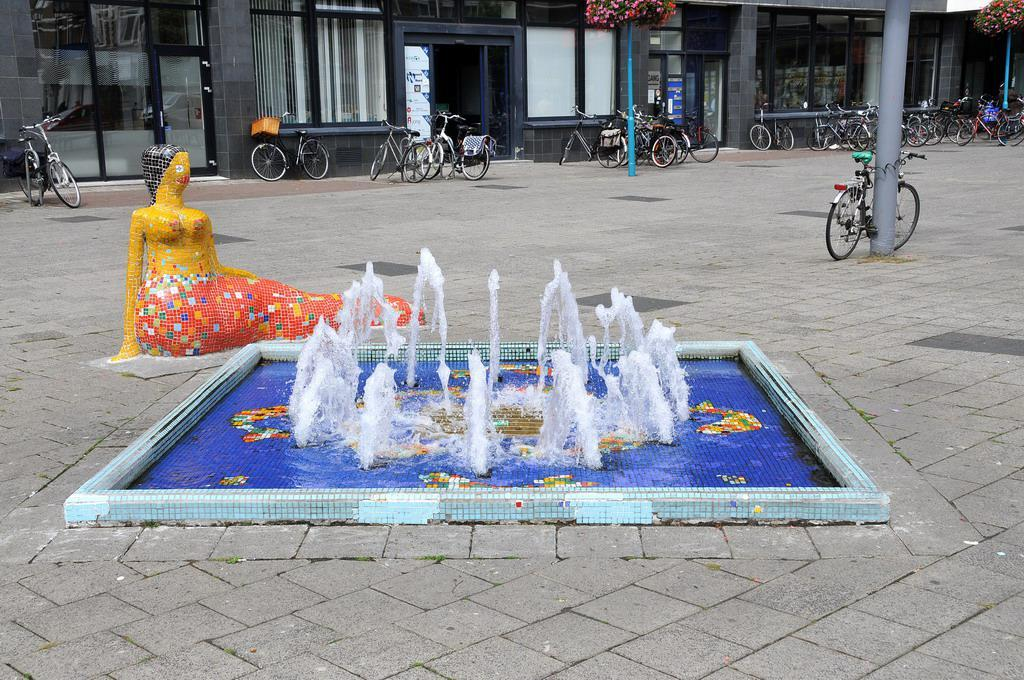What is the main feature in the image? There is a fountain with water in the image. Are there any other objects or structures near the fountain? Yes, there is a statue in the image. What can be seen on the ground in the image? There are bicycles on the ground in the image. What are the poles used for in the image? The purpose of the poles is not specified, but they are present in the image. What is located near the fountain? There is a basket in the image. What type of window treatment is visible in the image? There are windows with curtains in the image. What type of vegetation is present in the image? There are flowers in the image. What can be seen in the background of the image? There are buildings in the background of the image. Can you see any fairies flying around the fountain in the image? There are no fairies present in the image. What type of worm can be seen crawling on the statue in the image? There are no worms present in the image. 